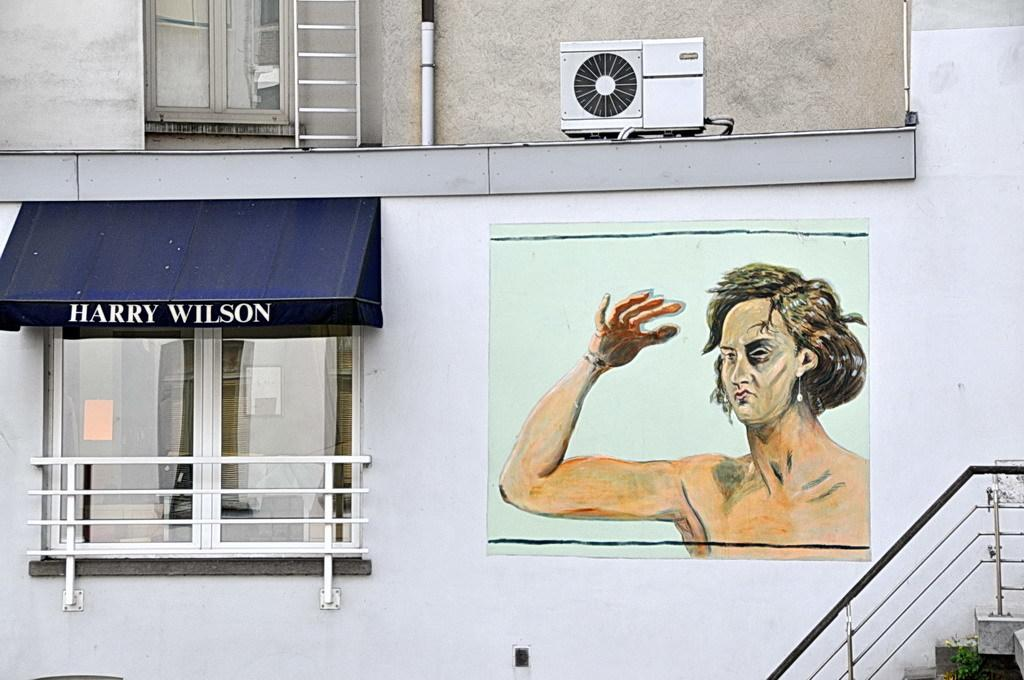What is the main structure in the center of the image? There is a wall in the center of the image. Can you see any openings in the wall? Yes, there is a window in the image. What architectural feature is located at the bottom of the image? There is a staircase at the bottom of the image. Is there any additional support for the staircase? Yes, there is a staircase railing in the image. What type of breakfast is being served in the image? There is no breakfast visible in the image. What attraction can be seen in the background of the image? There is no attraction visible in the image; it primarily features a wall, window, staircase, and railing. 